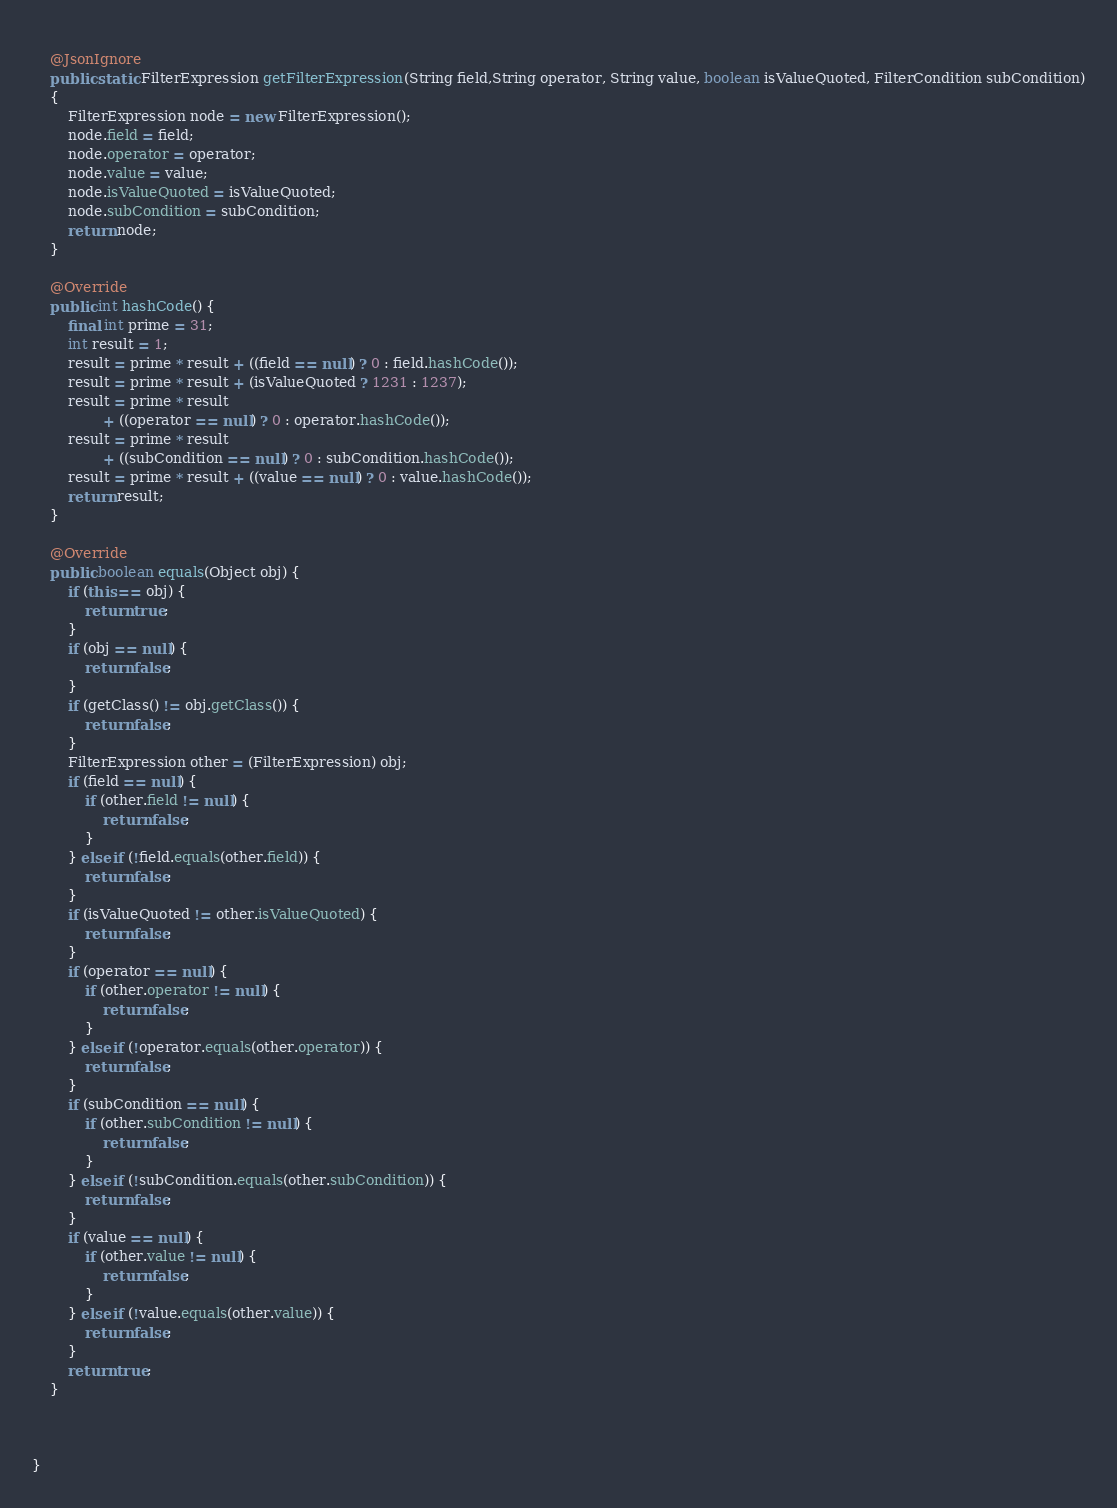Convert code to text. <code><loc_0><loc_0><loc_500><loc_500><_Java_>	
	@JsonIgnore
	public static FilterExpression getFilterExpression(String field,String operator, String value, boolean isValueQuoted, FilterCondition subCondition)
	{
		FilterExpression node = new FilterExpression();
		node.field = field;
		node.operator = operator;
		node.value = value;
		node.isValueQuoted = isValueQuoted;
		node.subCondition = subCondition;
		return node;
	}

	@Override
	public int hashCode() {
		final int prime = 31;
		int result = 1;
		result = prime * result + ((field == null) ? 0 : field.hashCode());
		result = prime * result + (isValueQuoted ? 1231 : 1237);
		result = prime * result
				+ ((operator == null) ? 0 : operator.hashCode());
		result = prime * result
				+ ((subCondition == null) ? 0 : subCondition.hashCode());
		result = prime * result + ((value == null) ? 0 : value.hashCode());
		return result;
	}

	@Override
	public boolean equals(Object obj) {
		if (this == obj) {
			return true;
		}
		if (obj == null) {
			return false;
		}
		if (getClass() != obj.getClass()) {
			return false;
		}
		FilterExpression other = (FilterExpression) obj;
		if (field == null) {
			if (other.field != null) {
				return false;
			}
		} else if (!field.equals(other.field)) {
			return false;
		}
		if (isValueQuoted != other.isValueQuoted) {
			return false;
		}
		if (operator == null) {
			if (other.operator != null) {
				return false;
			}
		} else if (!operator.equals(other.operator)) {
			return false;
		}
		if (subCondition == null) {
			if (other.subCondition != null) {
				return false;
			}
		} else if (!subCondition.equals(other.subCondition)) {
			return false;
		}
		if (value == null) {
			if (other.value != null) {
				return false;
			}
		} else if (!value.equals(other.value)) {
			return false;
		}
		return true;
	}
	
	

}
</code> 